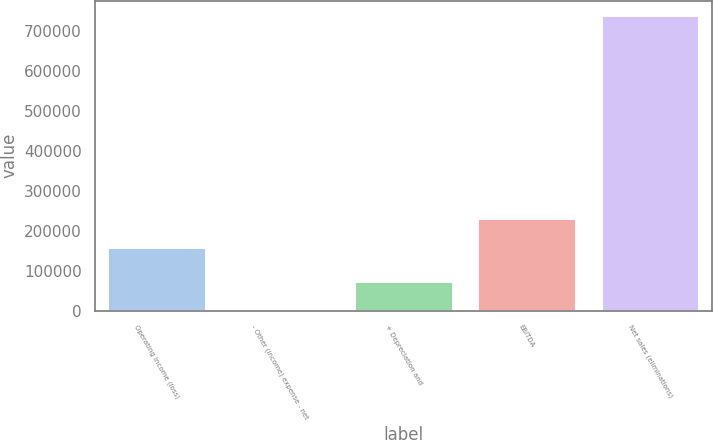Convert chart to OTSL. <chart><loc_0><loc_0><loc_500><loc_500><bar_chart><fcel>Operating income (loss)<fcel>- Other (income) expense - net<fcel>+ Depreciation and<fcel>EBITDA<fcel>Net sales (eliminations)<nl><fcel>158364<fcel>238<fcel>74113.8<fcel>232240<fcel>738996<nl></chart> 